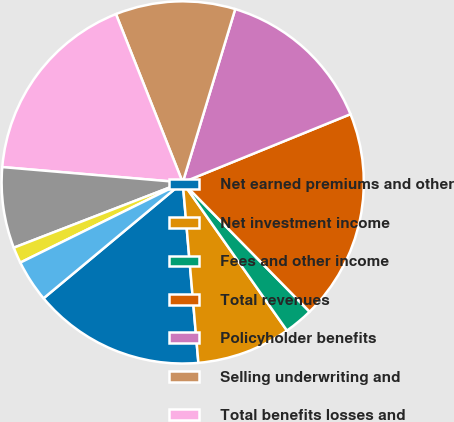Convert chart to OTSL. <chart><loc_0><loc_0><loc_500><loc_500><pie_chart><fcel>Net earned premiums and other<fcel>Net investment income<fcel>Fees and other income<fcel>Total revenues<fcel>Policyholder benefits<fcel>Selling underwriting and<fcel>Total benefits losses and<fcel>Segment income before income<fcel>Income taxes<fcel>Segment income after tax<nl><fcel>15.33%<fcel>8.38%<fcel>2.59%<fcel>18.8%<fcel>14.17%<fcel>10.69%<fcel>17.64%<fcel>7.22%<fcel>1.43%<fcel>3.75%<nl></chart> 